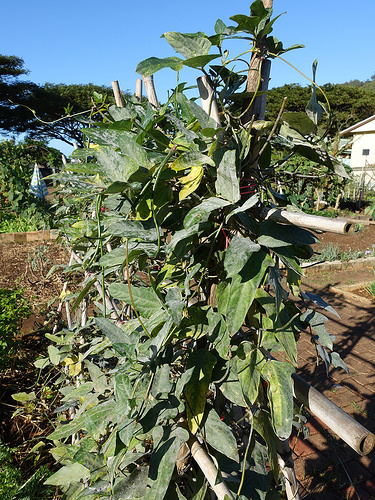<image>
Is there a plant on the field? Yes. Looking at the image, I can see the plant is positioned on top of the field, with the field providing support. 